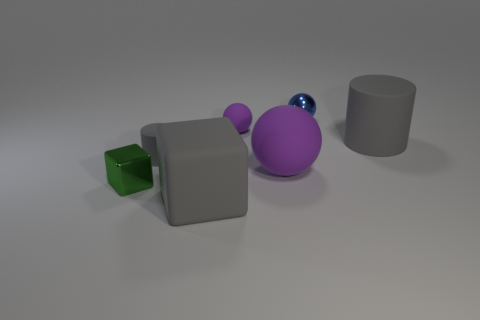What shape is the gray object that is the same size as the matte cube?
Provide a succinct answer. Cylinder. Is the number of tiny objects in front of the large purple rubber sphere the same as the number of tiny gray cylinders that are on the right side of the big matte cylinder?
Provide a succinct answer. No. There is a matte sphere behind the large gray matte object that is right of the large gray rubber block; how big is it?
Offer a very short reply. Small. Is there a rubber cylinder that has the same size as the green metal cube?
Offer a terse response. Yes. What is the color of the big sphere that is the same material as the large cylinder?
Your response must be concise. Purple. Is the number of metallic objects less than the number of green shiny blocks?
Provide a succinct answer. No. There is a sphere that is behind the large matte cylinder and on the right side of the small purple matte thing; what material is it?
Your answer should be very brief. Metal. There is a blue ball behind the tiny purple object; is there a gray rubber object that is on the left side of it?
Your answer should be very brief. Yes. How many other rubber cubes have the same color as the large matte cube?
Your answer should be compact. 0. What is the material of the large ball that is the same color as the tiny rubber sphere?
Your response must be concise. Rubber. 